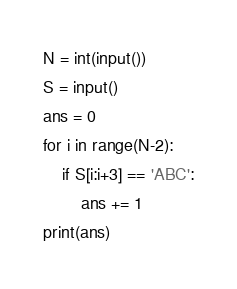Convert code to text. <code><loc_0><loc_0><loc_500><loc_500><_Python_>N = int(input())
S = input()
ans = 0
for i in range(N-2):
    if S[i:i+3] == 'ABC':
        ans += 1
print(ans)</code> 